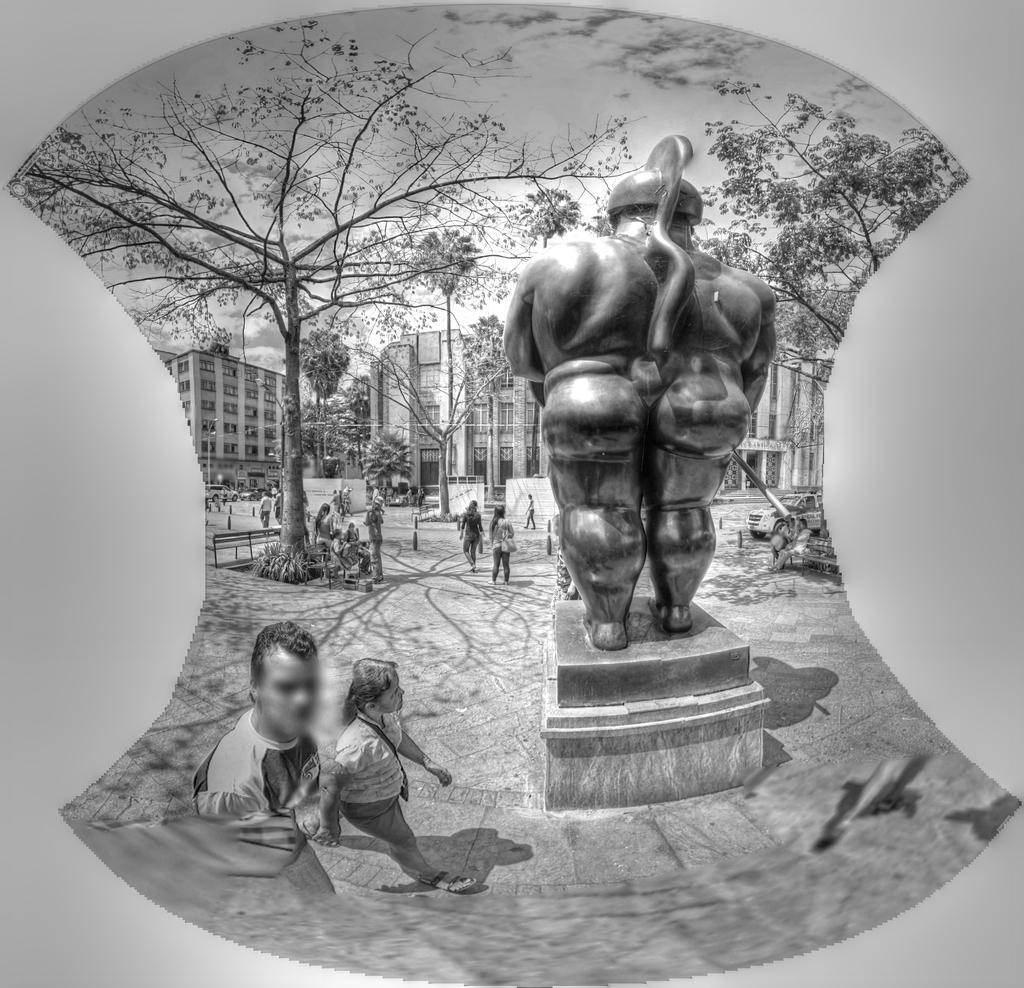What is happening on the ground in the image? There are people on the ground in the image. What is located on a platform in the image? There is a statue on a platform in the image. What can be seen in the background of the image? There are buildings, trees, and the sky visible in the background of the image. What type of bath is the statue taking in the image? There is no bath present in the image; it features a statue on a platform. What is the statue using to water the trees in the image? There is no hose or watering activity depicted in the image; it only shows a statue on a platform and people on the ground. 